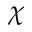<formula> <loc_0><loc_0><loc_500><loc_500>\chi</formula> 